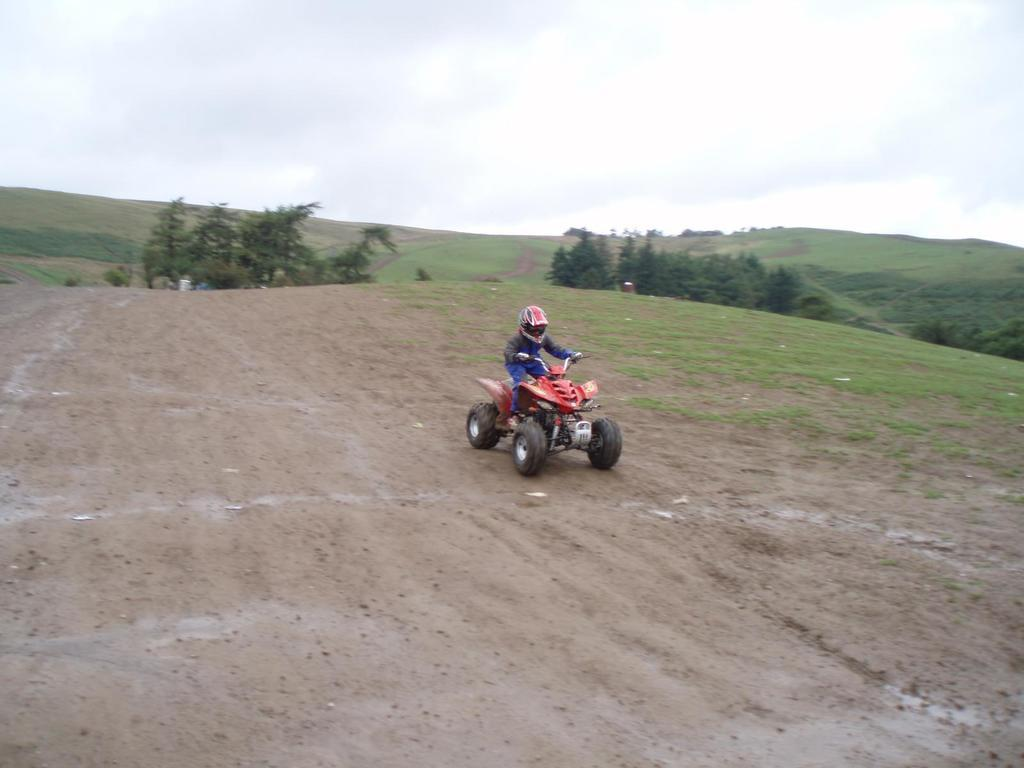Who is in the image? There is a person in the image. What is the person wearing? The person is wearing a helmet. What type of vehicle is the person on? The person is on an all-terrain vehicle. Where is the all-terrain vehicle located? The all-terrain vehicle is on the ground. What can be seen in the background of the image? There are trees, hills, and the sky visible in the background of the image. What is the condition of the sky in the image? Clouds are present in the sky. How many servants are attending to the person in the image? There are no servants present in the image. What addition has the person made to the all-terrain vehicle in the image? There is no indication of any additions made to the all-terrain vehicle in the image. 